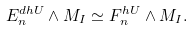Convert formula to latex. <formula><loc_0><loc_0><loc_500><loc_500>E _ { n } ^ { d h U } \wedge M _ { I } \simeq F _ { n } ^ { h U } \wedge M _ { I } .</formula> 